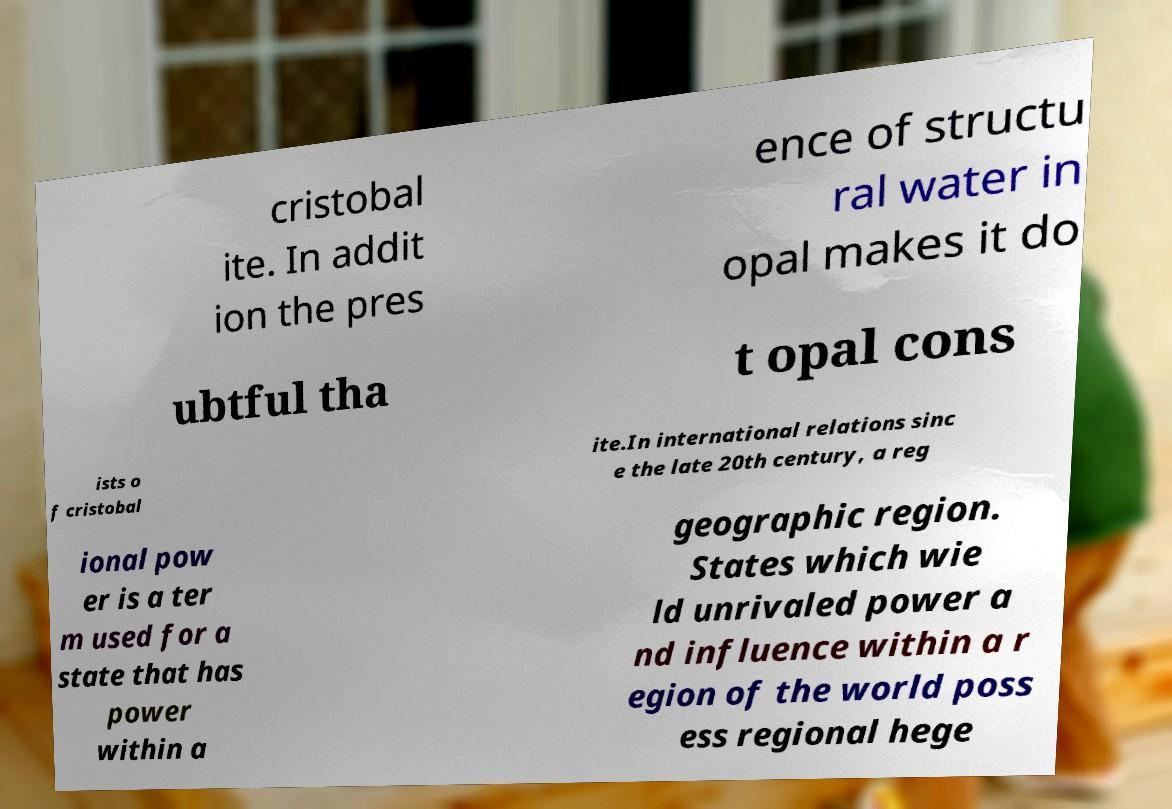Can you read and provide the text displayed in the image?This photo seems to have some interesting text. Can you extract and type it out for me? cristobal ite. In addit ion the pres ence of structu ral water in opal makes it do ubtful tha t opal cons ists o f cristobal ite.In international relations sinc e the late 20th century, a reg ional pow er is a ter m used for a state that has power within a geographic region. States which wie ld unrivaled power a nd influence within a r egion of the world poss ess regional hege 